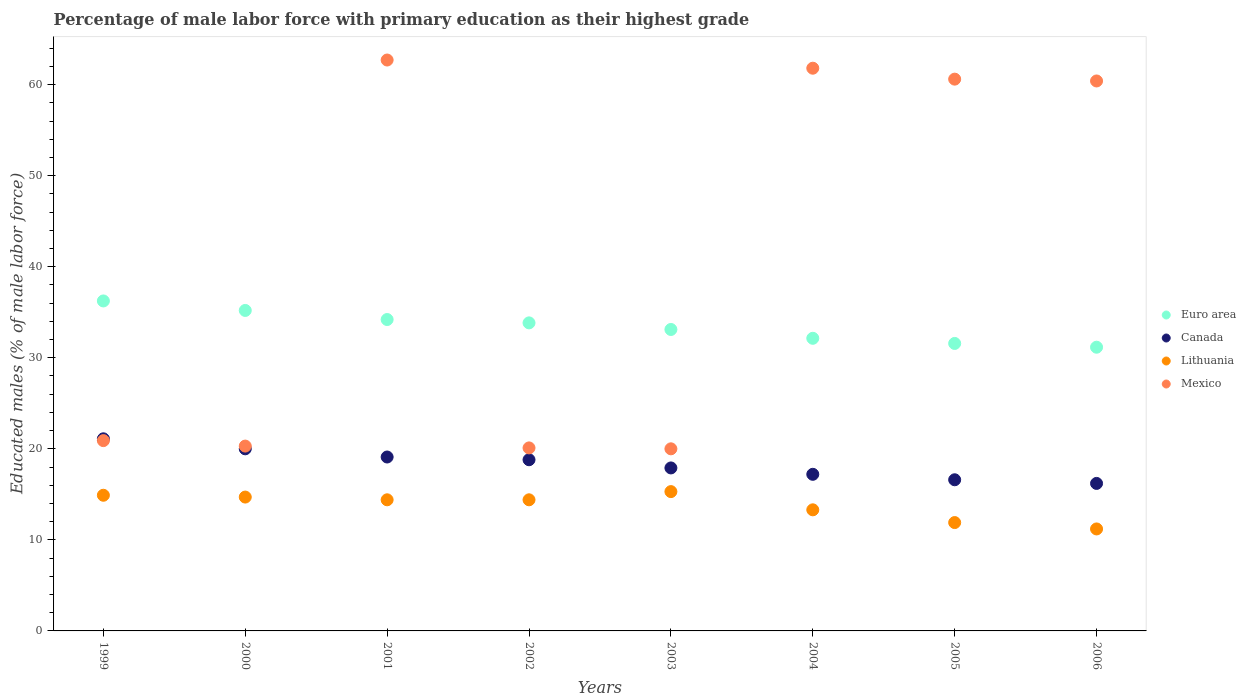How many different coloured dotlines are there?
Keep it short and to the point. 4. What is the percentage of male labor force with primary education in Mexico in 2002?
Your answer should be very brief. 20.1. Across all years, what is the maximum percentage of male labor force with primary education in Mexico?
Offer a terse response. 62.7. Across all years, what is the minimum percentage of male labor force with primary education in Mexico?
Your answer should be compact. 20. In which year was the percentage of male labor force with primary education in Mexico maximum?
Your answer should be compact. 2001. What is the total percentage of male labor force with primary education in Canada in the graph?
Provide a succinct answer. 146.9. What is the difference between the percentage of male labor force with primary education in Canada in 2004 and that in 2005?
Provide a succinct answer. 0.6. What is the difference between the percentage of male labor force with primary education in Euro area in 2002 and the percentage of male labor force with primary education in Canada in 1999?
Your answer should be very brief. 12.73. What is the average percentage of male labor force with primary education in Canada per year?
Offer a terse response. 18.36. In the year 1999, what is the difference between the percentage of male labor force with primary education in Canada and percentage of male labor force with primary education in Lithuania?
Provide a succinct answer. 6.2. In how many years, is the percentage of male labor force with primary education in Lithuania greater than 36 %?
Ensure brevity in your answer.  0. What is the ratio of the percentage of male labor force with primary education in Mexico in 2004 to that in 2006?
Keep it short and to the point. 1.02. What is the difference between the highest and the second highest percentage of male labor force with primary education in Euro area?
Give a very brief answer. 1.04. What is the difference between the highest and the lowest percentage of male labor force with primary education in Mexico?
Make the answer very short. 42.7. In how many years, is the percentage of male labor force with primary education in Canada greater than the average percentage of male labor force with primary education in Canada taken over all years?
Provide a short and direct response. 4. Does the percentage of male labor force with primary education in Canada monotonically increase over the years?
Your answer should be compact. No. How many years are there in the graph?
Keep it short and to the point. 8. Does the graph contain any zero values?
Give a very brief answer. No. Where does the legend appear in the graph?
Ensure brevity in your answer.  Center right. How many legend labels are there?
Offer a terse response. 4. What is the title of the graph?
Make the answer very short. Percentage of male labor force with primary education as their highest grade. What is the label or title of the X-axis?
Your answer should be very brief. Years. What is the label or title of the Y-axis?
Your answer should be very brief. Educated males (% of male labor force). What is the Educated males (% of male labor force) in Euro area in 1999?
Your answer should be very brief. 36.24. What is the Educated males (% of male labor force) of Canada in 1999?
Make the answer very short. 21.1. What is the Educated males (% of male labor force) in Lithuania in 1999?
Make the answer very short. 14.9. What is the Educated males (% of male labor force) in Mexico in 1999?
Offer a very short reply. 20.9. What is the Educated males (% of male labor force) in Euro area in 2000?
Offer a terse response. 35.2. What is the Educated males (% of male labor force) of Lithuania in 2000?
Make the answer very short. 14.7. What is the Educated males (% of male labor force) in Mexico in 2000?
Ensure brevity in your answer.  20.3. What is the Educated males (% of male labor force) of Euro area in 2001?
Provide a short and direct response. 34.2. What is the Educated males (% of male labor force) of Canada in 2001?
Offer a terse response. 19.1. What is the Educated males (% of male labor force) of Lithuania in 2001?
Offer a very short reply. 14.4. What is the Educated males (% of male labor force) in Mexico in 2001?
Keep it short and to the point. 62.7. What is the Educated males (% of male labor force) in Euro area in 2002?
Keep it short and to the point. 33.83. What is the Educated males (% of male labor force) of Canada in 2002?
Offer a very short reply. 18.8. What is the Educated males (% of male labor force) in Lithuania in 2002?
Ensure brevity in your answer.  14.4. What is the Educated males (% of male labor force) in Mexico in 2002?
Give a very brief answer. 20.1. What is the Educated males (% of male labor force) of Euro area in 2003?
Provide a succinct answer. 33.11. What is the Educated males (% of male labor force) of Canada in 2003?
Your answer should be compact. 17.9. What is the Educated males (% of male labor force) in Lithuania in 2003?
Provide a succinct answer. 15.3. What is the Educated males (% of male labor force) in Euro area in 2004?
Give a very brief answer. 32.14. What is the Educated males (% of male labor force) of Canada in 2004?
Your response must be concise. 17.2. What is the Educated males (% of male labor force) in Lithuania in 2004?
Your answer should be compact. 13.3. What is the Educated males (% of male labor force) in Mexico in 2004?
Offer a very short reply. 61.8. What is the Educated males (% of male labor force) of Euro area in 2005?
Make the answer very short. 31.57. What is the Educated males (% of male labor force) in Canada in 2005?
Offer a very short reply. 16.6. What is the Educated males (% of male labor force) in Lithuania in 2005?
Your response must be concise. 11.9. What is the Educated males (% of male labor force) in Mexico in 2005?
Give a very brief answer. 60.6. What is the Educated males (% of male labor force) in Euro area in 2006?
Provide a succinct answer. 31.16. What is the Educated males (% of male labor force) of Canada in 2006?
Give a very brief answer. 16.2. What is the Educated males (% of male labor force) of Lithuania in 2006?
Offer a very short reply. 11.2. What is the Educated males (% of male labor force) of Mexico in 2006?
Your answer should be very brief. 60.4. Across all years, what is the maximum Educated males (% of male labor force) of Euro area?
Ensure brevity in your answer.  36.24. Across all years, what is the maximum Educated males (% of male labor force) of Canada?
Your response must be concise. 21.1. Across all years, what is the maximum Educated males (% of male labor force) in Lithuania?
Your response must be concise. 15.3. Across all years, what is the maximum Educated males (% of male labor force) of Mexico?
Your answer should be very brief. 62.7. Across all years, what is the minimum Educated males (% of male labor force) in Euro area?
Make the answer very short. 31.16. Across all years, what is the minimum Educated males (% of male labor force) of Canada?
Provide a succinct answer. 16.2. Across all years, what is the minimum Educated males (% of male labor force) of Lithuania?
Your response must be concise. 11.2. What is the total Educated males (% of male labor force) in Euro area in the graph?
Your answer should be compact. 267.44. What is the total Educated males (% of male labor force) in Canada in the graph?
Provide a succinct answer. 146.9. What is the total Educated males (% of male labor force) in Lithuania in the graph?
Your answer should be very brief. 110.1. What is the total Educated males (% of male labor force) of Mexico in the graph?
Offer a very short reply. 326.8. What is the difference between the Educated males (% of male labor force) in Euro area in 1999 and that in 2000?
Keep it short and to the point. 1.04. What is the difference between the Educated males (% of male labor force) of Euro area in 1999 and that in 2001?
Provide a succinct answer. 2.04. What is the difference between the Educated males (% of male labor force) in Canada in 1999 and that in 2001?
Provide a short and direct response. 2. What is the difference between the Educated males (% of male labor force) of Lithuania in 1999 and that in 2001?
Ensure brevity in your answer.  0.5. What is the difference between the Educated males (% of male labor force) of Mexico in 1999 and that in 2001?
Your response must be concise. -41.8. What is the difference between the Educated males (% of male labor force) of Euro area in 1999 and that in 2002?
Offer a terse response. 2.41. What is the difference between the Educated males (% of male labor force) of Mexico in 1999 and that in 2002?
Provide a short and direct response. 0.8. What is the difference between the Educated males (% of male labor force) in Euro area in 1999 and that in 2003?
Keep it short and to the point. 3.13. What is the difference between the Educated males (% of male labor force) in Lithuania in 1999 and that in 2003?
Offer a very short reply. -0.4. What is the difference between the Educated males (% of male labor force) in Euro area in 1999 and that in 2004?
Provide a short and direct response. 4.1. What is the difference between the Educated males (% of male labor force) in Lithuania in 1999 and that in 2004?
Give a very brief answer. 1.6. What is the difference between the Educated males (% of male labor force) of Mexico in 1999 and that in 2004?
Provide a succinct answer. -40.9. What is the difference between the Educated males (% of male labor force) in Euro area in 1999 and that in 2005?
Give a very brief answer. 4.67. What is the difference between the Educated males (% of male labor force) in Mexico in 1999 and that in 2005?
Give a very brief answer. -39.7. What is the difference between the Educated males (% of male labor force) in Euro area in 1999 and that in 2006?
Your answer should be compact. 5.08. What is the difference between the Educated males (% of male labor force) of Canada in 1999 and that in 2006?
Give a very brief answer. 4.9. What is the difference between the Educated males (% of male labor force) of Lithuania in 1999 and that in 2006?
Your answer should be very brief. 3.7. What is the difference between the Educated males (% of male labor force) of Mexico in 1999 and that in 2006?
Offer a very short reply. -39.5. What is the difference between the Educated males (% of male labor force) of Canada in 2000 and that in 2001?
Your response must be concise. 0.9. What is the difference between the Educated males (% of male labor force) in Lithuania in 2000 and that in 2001?
Make the answer very short. 0.3. What is the difference between the Educated males (% of male labor force) of Mexico in 2000 and that in 2001?
Your response must be concise. -42.4. What is the difference between the Educated males (% of male labor force) in Euro area in 2000 and that in 2002?
Provide a short and direct response. 1.36. What is the difference between the Educated males (% of male labor force) of Canada in 2000 and that in 2002?
Your response must be concise. 1.2. What is the difference between the Educated males (% of male labor force) of Lithuania in 2000 and that in 2002?
Your answer should be compact. 0.3. What is the difference between the Educated males (% of male labor force) in Mexico in 2000 and that in 2002?
Your response must be concise. 0.2. What is the difference between the Educated males (% of male labor force) of Euro area in 2000 and that in 2003?
Offer a terse response. 2.09. What is the difference between the Educated males (% of male labor force) of Canada in 2000 and that in 2003?
Provide a short and direct response. 2.1. What is the difference between the Educated males (% of male labor force) of Mexico in 2000 and that in 2003?
Make the answer very short. 0.3. What is the difference between the Educated males (% of male labor force) of Euro area in 2000 and that in 2004?
Your response must be concise. 3.06. What is the difference between the Educated males (% of male labor force) in Canada in 2000 and that in 2004?
Your answer should be very brief. 2.8. What is the difference between the Educated males (% of male labor force) of Mexico in 2000 and that in 2004?
Ensure brevity in your answer.  -41.5. What is the difference between the Educated males (% of male labor force) of Euro area in 2000 and that in 2005?
Your response must be concise. 3.62. What is the difference between the Educated males (% of male labor force) in Canada in 2000 and that in 2005?
Your answer should be very brief. 3.4. What is the difference between the Educated males (% of male labor force) of Mexico in 2000 and that in 2005?
Give a very brief answer. -40.3. What is the difference between the Educated males (% of male labor force) of Euro area in 2000 and that in 2006?
Give a very brief answer. 4.04. What is the difference between the Educated males (% of male labor force) in Canada in 2000 and that in 2006?
Ensure brevity in your answer.  3.8. What is the difference between the Educated males (% of male labor force) of Lithuania in 2000 and that in 2006?
Provide a short and direct response. 3.5. What is the difference between the Educated males (% of male labor force) of Mexico in 2000 and that in 2006?
Your answer should be compact. -40.1. What is the difference between the Educated males (% of male labor force) in Euro area in 2001 and that in 2002?
Offer a terse response. 0.37. What is the difference between the Educated males (% of male labor force) in Canada in 2001 and that in 2002?
Your response must be concise. 0.3. What is the difference between the Educated males (% of male labor force) in Lithuania in 2001 and that in 2002?
Make the answer very short. 0. What is the difference between the Educated males (% of male labor force) in Mexico in 2001 and that in 2002?
Your answer should be very brief. 42.6. What is the difference between the Educated males (% of male labor force) in Euro area in 2001 and that in 2003?
Provide a short and direct response. 1.09. What is the difference between the Educated males (% of male labor force) of Canada in 2001 and that in 2003?
Your answer should be very brief. 1.2. What is the difference between the Educated males (% of male labor force) in Mexico in 2001 and that in 2003?
Give a very brief answer. 42.7. What is the difference between the Educated males (% of male labor force) in Euro area in 2001 and that in 2004?
Make the answer very short. 2.06. What is the difference between the Educated males (% of male labor force) in Canada in 2001 and that in 2004?
Offer a very short reply. 1.9. What is the difference between the Educated males (% of male labor force) of Lithuania in 2001 and that in 2004?
Offer a very short reply. 1.1. What is the difference between the Educated males (% of male labor force) in Mexico in 2001 and that in 2004?
Offer a terse response. 0.9. What is the difference between the Educated males (% of male labor force) in Euro area in 2001 and that in 2005?
Give a very brief answer. 2.63. What is the difference between the Educated males (% of male labor force) in Canada in 2001 and that in 2005?
Keep it short and to the point. 2.5. What is the difference between the Educated males (% of male labor force) of Euro area in 2001 and that in 2006?
Make the answer very short. 3.04. What is the difference between the Educated males (% of male labor force) of Canada in 2001 and that in 2006?
Ensure brevity in your answer.  2.9. What is the difference between the Educated males (% of male labor force) in Lithuania in 2001 and that in 2006?
Your response must be concise. 3.2. What is the difference between the Educated males (% of male labor force) of Euro area in 2002 and that in 2003?
Your answer should be compact. 0.72. What is the difference between the Educated males (% of male labor force) of Canada in 2002 and that in 2003?
Provide a succinct answer. 0.9. What is the difference between the Educated males (% of male labor force) in Lithuania in 2002 and that in 2003?
Offer a terse response. -0.9. What is the difference between the Educated males (% of male labor force) of Mexico in 2002 and that in 2003?
Offer a terse response. 0.1. What is the difference between the Educated males (% of male labor force) in Euro area in 2002 and that in 2004?
Make the answer very short. 1.69. What is the difference between the Educated males (% of male labor force) of Mexico in 2002 and that in 2004?
Your answer should be compact. -41.7. What is the difference between the Educated males (% of male labor force) in Euro area in 2002 and that in 2005?
Offer a terse response. 2.26. What is the difference between the Educated males (% of male labor force) in Mexico in 2002 and that in 2005?
Your answer should be very brief. -40.5. What is the difference between the Educated males (% of male labor force) of Euro area in 2002 and that in 2006?
Offer a terse response. 2.67. What is the difference between the Educated males (% of male labor force) in Canada in 2002 and that in 2006?
Your answer should be compact. 2.6. What is the difference between the Educated males (% of male labor force) in Mexico in 2002 and that in 2006?
Your answer should be very brief. -40.3. What is the difference between the Educated males (% of male labor force) of Euro area in 2003 and that in 2004?
Your answer should be very brief. 0.97. What is the difference between the Educated males (% of male labor force) of Mexico in 2003 and that in 2004?
Your answer should be very brief. -41.8. What is the difference between the Educated males (% of male labor force) in Euro area in 2003 and that in 2005?
Your answer should be compact. 1.53. What is the difference between the Educated males (% of male labor force) in Mexico in 2003 and that in 2005?
Provide a short and direct response. -40.6. What is the difference between the Educated males (% of male labor force) in Euro area in 2003 and that in 2006?
Offer a very short reply. 1.95. What is the difference between the Educated males (% of male labor force) of Mexico in 2003 and that in 2006?
Offer a terse response. -40.4. What is the difference between the Educated males (% of male labor force) in Euro area in 2004 and that in 2005?
Give a very brief answer. 0.57. What is the difference between the Educated males (% of male labor force) of Canada in 2004 and that in 2005?
Give a very brief answer. 0.6. What is the difference between the Educated males (% of male labor force) in Euro area in 2004 and that in 2006?
Provide a succinct answer. 0.98. What is the difference between the Educated males (% of male labor force) in Lithuania in 2004 and that in 2006?
Keep it short and to the point. 2.1. What is the difference between the Educated males (% of male labor force) of Mexico in 2004 and that in 2006?
Provide a succinct answer. 1.4. What is the difference between the Educated males (% of male labor force) of Euro area in 2005 and that in 2006?
Offer a terse response. 0.41. What is the difference between the Educated males (% of male labor force) of Lithuania in 2005 and that in 2006?
Offer a very short reply. 0.7. What is the difference between the Educated males (% of male labor force) in Euro area in 1999 and the Educated males (% of male labor force) in Canada in 2000?
Your answer should be compact. 16.24. What is the difference between the Educated males (% of male labor force) of Euro area in 1999 and the Educated males (% of male labor force) of Lithuania in 2000?
Offer a terse response. 21.54. What is the difference between the Educated males (% of male labor force) of Euro area in 1999 and the Educated males (% of male labor force) of Mexico in 2000?
Make the answer very short. 15.94. What is the difference between the Educated males (% of male labor force) in Canada in 1999 and the Educated males (% of male labor force) in Lithuania in 2000?
Offer a very short reply. 6.4. What is the difference between the Educated males (% of male labor force) of Canada in 1999 and the Educated males (% of male labor force) of Mexico in 2000?
Your answer should be very brief. 0.8. What is the difference between the Educated males (% of male labor force) of Lithuania in 1999 and the Educated males (% of male labor force) of Mexico in 2000?
Your answer should be compact. -5.4. What is the difference between the Educated males (% of male labor force) of Euro area in 1999 and the Educated males (% of male labor force) of Canada in 2001?
Your answer should be compact. 17.14. What is the difference between the Educated males (% of male labor force) in Euro area in 1999 and the Educated males (% of male labor force) in Lithuania in 2001?
Make the answer very short. 21.84. What is the difference between the Educated males (% of male labor force) of Euro area in 1999 and the Educated males (% of male labor force) of Mexico in 2001?
Ensure brevity in your answer.  -26.46. What is the difference between the Educated males (% of male labor force) of Canada in 1999 and the Educated males (% of male labor force) of Lithuania in 2001?
Offer a terse response. 6.7. What is the difference between the Educated males (% of male labor force) in Canada in 1999 and the Educated males (% of male labor force) in Mexico in 2001?
Provide a succinct answer. -41.6. What is the difference between the Educated males (% of male labor force) in Lithuania in 1999 and the Educated males (% of male labor force) in Mexico in 2001?
Make the answer very short. -47.8. What is the difference between the Educated males (% of male labor force) of Euro area in 1999 and the Educated males (% of male labor force) of Canada in 2002?
Offer a terse response. 17.44. What is the difference between the Educated males (% of male labor force) of Euro area in 1999 and the Educated males (% of male labor force) of Lithuania in 2002?
Provide a short and direct response. 21.84. What is the difference between the Educated males (% of male labor force) in Euro area in 1999 and the Educated males (% of male labor force) in Mexico in 2002?
Provide a succinct answer. 16.14. What is the difference between the Educated males (% of male labor force) of Canada in 1999 and the Educated males (% of male labor force) of Lithuania in 2002?
Offer a terse response. 6.7. What is the difference between the Educated males (% of male labor force) in Euro area in 1999 and the Educated males (% of male labor force) in Canada in 2003?
Provide a succinct answer. 18.34. What is the difference between the Educated males (% of male labor force) in Euro area in 1999 and the Educated males (% of male labor force) in Lithuania in 2003?
Offer a very short reply. 20.94. What is the difference between the Educated males (% of male labor force) of Euro area in 1999 and the Educated males (% of male labor force) of Mexico in 2003?
Keep it short and to the point. 16.24. What is the difference between the Educated males (% of male labor force) in Canada in 1999 and the Educated males (% of male labor force) in Lithuania in 2003?
Your response must be concise. 5.8. What is the difference between the Educated males (% of male labor force) in Canada in 1999 and the Educated males (% of male labor force) in Mexico in 2003?
Offer a very short reply. 1.1. What is the difference between the Educated males (% of male labor force) of Euro area in 1999 and the Educated males (% of male labor force) of Canada in 2004?
Provide a short and direct response. 19.04. What is the difference between the Educated males (% of male labor force) of Euro area in 1999 and the Educated males (% of male labor force) of Lithuania in 2004?
Provide a succinct answer. 22.94. What is the difference between the Educated males (% of male labor force) of Euro area in 1999 and the Educated males (% of male labor force) of Mexico in 2004?
Give a very brief answer. -25.56. What is the difference between the Educated males (% of male labor force) of Canada in 1999 and the Educated males (% of male labor force) of Lithuania in 2004?
Your response must be concise. 7.8. What is the difference between the Educated males (% of male labor force) in Canada in 1999 and the Educated males (% of male labor force) in Mexico in 2004?
Make the answer very short. -40.7. What is the difference between the Educated males (% of male labor force) of Lithuania in 1999 and the Educated males (% of male labor force) of Mexico in 2004?
Make the answer very short. -46.9. What is the difference between the Educated males (% of male labor force) in Euro area in 1999 and the Educated males (% of male labor force) in Canada in 2005?
Ensure brevity in your answer.  19.64. What is the difference between the Educated males (% of male labor force) in Euro area in 1999 and the Educated males (% of male labor force) in Lithuania in 2005?
Offer a terse response. 24.34. What is the difference between the Educated males (% of male labor force) in Euro area in 1999 and the Educated males (% of male labor force) in Mexico in 2005?
Provide a succinct answer. -24.36. What is the difference between the Educated males (% of male labor force) of Canada in 1999 and the Educated males (% of male labor force) of Mexico in 2005?
Provide a short and direct response. -39.5. What is the difference between the Educated males (% of male labor force) in Lithuania in 1999 and the Educated males (% of male labor force) in Mexico in 2005?
Make the answer very short. -45.7. What is the difference between the Educated males (% of male labor force) of Euro area in 1999 and the Educated males (% of male labor force) of Canada in 2006?
Provide a succinct answer. 20.04. What is the difference between the Educated males (% of male labor force) in Euro area in 1999 and the Educated males (% of male labor force) in Lithuania in 2006?
Give a very brief answer. 25.04. What is the difference between the Educated males (% of male labor force) of Euro area in 1999 and the Educated males (% of male labor force) of Mexico in 2006?
Your answer should be very brief. -24.16. What is the difference between the Educated males (% of male labor force) of Canada in 1999 and the Educated males (% of male labor force) of Mexico in 2006?
Offer a very short reply. -39.3. What is the difference between the Educated males (% of male labor force) of Lithuania in 1999 and the Educated males (% of male labor force) of Mexico in 2006?
Keep it short and to the point. -45.5. What is the difference between the Educated males (% of male labor force) in Euro area in 2000 and the Educated males (% of male labor force) in Canada in 2001?
Offer a terse response. 16.1. What is the difference between the Educated males (% of male labor force) in Euro area in 2000 and the Educated males (% of male labor force) in Lithuania in 2001?
Give a very brief answer. 20.8. What is the difference between the Educated males (% of male labor force) of Euro area in 2000 and the Educated males (% of male labor force) of Mexico in 2001?
Keep it short and to the point. -27.5. What is the difference between the Educated males (% of male labor force) in Canada in 2000 and the Educated males (% of male labor force) in Mexico in 2001?
Your answer should be compact. -42.7. What is the difference between the Educated males (% of male labor force) of Lithuania in 2000 and the Educated males (% of male labor force) of Mexico in 2001?
Your answer should be very brief. -48. What is the difference between the Educated males (% of male labor force) of Euro area in 2000 and the Educated males (% of male labor force) of Canada in 2002?
Provide a short and direct response. 16.4. What is the difference between the Educated males (% of male labor force) in Euro area in 2000 and the Educated males (% of male labor force) in Lithuania in 2002?
Offer a very short reply. 20.8. What is the difference between the Educated males (% of male labor force) in Euro area in 2000 and the Educated males (% of male labor force) in Mexico in 2002?
Provide a succinct answer. 15.1. What is the difference between the Educated males (% of male labor force) of Lithuania in 2000 and the Educated males (% of male labor force) of Mexico in 2002?
Offer a terse response. -5.4. What is the difference between the Educated males (% of male labor force) of Euro area in 2000 and the Educated males (% of male labor force) of Canada in 2003?
Offer a very short reply. 17.3. What is the difference between the Educated males (% of male labor force) in Euro area in 2000 and the Educated males (% of male labor force) in Lithuania in 2003?
Provide a succinct answer. 19.9. What is the difference between the Educated males (% of male labor force) of Euro area in 2000 and the Educated males (% of male labor force) of Mexico in 2003?
Make the answer very short. 15.2. What is the difference between the Educated males (% of male labor force) of Canada in 2000 and the Educated males (% of male labor force) of Lithuania in 2003?
Your answer should be very brief. 4.7. What is the difference between the Educated males (% of male labor force) in Lithuania in 2000 and the Educated males (% of male labor force) in Mexico in 2003?
Your answer should be very brief. -5.3. What is the difference between the Educated males (% of male labor force) in Euro area in 2000 and the Educated males (% of male labor force) in Canada in 2004?
Ensure brevity in your answer.  18. What is the difference between the Educated males (% of male labor force) of Euro area in 2000 and the Educated males (% of male labor force) of Lithuania in 2004?
Keep it short and to the point. 21.9. What is the difference between the Educated males (% of male labor force) of Euro area in 2000 and the Educated males (% of male labor force) of Mexico in 2004?
Make the answer very short. -26.6. What is the difference between the Educated males (% of male labor force) in Canada in 2000 and the Educated males (% of male labor force) in Mexico in 2004?
Make the answer very short. -41.8. What is the difference between the Educated males (% of male labor force) of Lithuania in 2000 and the Educated males (% of male labor force) of Mexico in 2004?
Offer a terse response. -47.1. What is the difference between the Educated males (% of male labor force) in Euro area in 2000 and the Educated males (% of male labor force) in Canada in 2005?
Ensure brevity in your answer.  18.6. What is the difference between the Educated males (% of male labor force) in Euro area in 2000 and the Educated males (% of male labor force) in Lithuania in 2005?
Provide a short and direct response. 23.3. What is the difference between the Educated males (% of male labor force) in Euro area in 2000 and the Educated males (% of male labor force) in Mexico in 2005?
Your answer should be compact. -25.4. What is the difference between the Educated males (% of male labor force) of Canada in 2000 and the Educated males (% of male labor force) of Mexico in 2005?
Provide a short and direct response. -40.6. What is the difference between the Educated males (% of male labor force) of Lithuania in 2000 and the Educated males (% of male labor force) of Mexico in 2005?
Provide a succinct answer. -45.9. What is the difference between the Educated males (% of male labor force) of Euro area in 2000 and the Educated males (% of male labor force) of Canada in 2006?
Offer a terse response. 19. What is the difference between the Educated males (% of male labor force) in Euro area in 2000 and the Educated males (% of male labor force) in Lithuania in 2006?
Your answer should be compact. 24. What is the difference between the Educated males (% of male labor force) in Euro area in 2000 and the Educated males (% of male labor force) in Mexico in 2006?
Provide a succinct answer. -25.2. What is the difference between the Educated males (% of male labor force) in Canada in 2000 and the Educated males (% of male labor force) in Lithuania in 2006?
Make the answer very short. 8.8. What is the difference between the Educated males (% of male labor force) in Canada in 2000 and the Educated males (% of male labor force) in Mexico in 2006?
Offer a terse response. -40.4. What is the difference between the Educated males (% of male labor force) of Lithuania in 2000 and the Educated males (% of male labor force) of Mexico in 2006?
Your answer should be compact. -45.7. What is the difference between the Educated males (% of male labor force) of Euro area in 2001 and the Educated males (% of male labor force) of Canada in 2002?
Ensure brevity in your answer.  15.4. What is the difference between the Educated males (% of male labor force) in Euro area in 2001 and the Educated males (% of male labor force) in Lithuania in 2002?
Keep it short and to the point. 19.8. What is the difference between the Educated males (% of male labor force) in Euro area in 2001 and the Educated males (% of male labor force) in Mexico in 2002?
Your answer should be very brief. 14.1. What is the difference between the Educated males (% of male labor force) of Canada in 2001 and the Educated males (% of male labor force) of Lithuania in 2002?
Your answer should be very brief. 4.7. What is the difference between the Educated males (% of male labor force) of Lithuania in 2001 and the Educated males (% of male labor force) of Mexico in 2002?
Give a very brief answer. -5.7. What is the difference between the Educated males (% of male labor force) in Euro area in 2001 and the Educated males (% of male labor force) in Canada in 2003?
Offer a very short reply. 16.3. What is the difference between the Educated males (% of male labor force) in Euro area in 2001 and the Educated males (% of male labor force) in Lithuania in 2003?
Offer a very short reply. 18.9. What is the difference between the Educated males (% of male labor force) of Euro area in 2001 and the Educated males (% of male labor force) of Mexico in 2003?
Your answer should be compact. 14.2. What is the difference between the Educated males (% of male labor force) in Canada in 2001 and the Educated males (% of male labor force) in Lithuania in 2003?
Keep it short and to the point. 3.8. What is the difference between the Educated males (% of male labor force) in Canada in 2001 and the Educated males (% of male labor force) in Mexico in 2003?
Your answer should be very brief. -0.9. What is the difference between the Educated males (% of male labor force) of Lithuania in 2001 and the Educated males (% of male labor force) of Mexico in 2003?
Give a very brief answer. -5.6. What is the difference between the Educated males (% of male labor force) of Euro area in 2001 and the Educated males (% of male labor force) of Canada in 2004?
Keep it short and to the point. 17. What is the difference between the Educated males (% of male labor force) of Euro area in 2001 and the Educated males (% of male labor force) of Lithuania in 2004?
Provide a short and direct response. 20.9. What is the difference between the Educated males (% of male labor force) of Euro area in 2001 and the Educated males (% of male labor force) of Mexico in 2004?
Provide a succinct answer. -27.6. What is the difference between the Educated males (% of male labor force) of Canada in 2001 and the Educated males (% of male labor force) of Mexico in 2004?
Provide a succinct answer. -42.7. What is the difference between the Educated males (% of male labor force) in Lithuania in 2001 and the Educated males (% of male labor force) in Mexico in 2004?
Offer a very short reply. -47.4. What is the difference between the Educated males (% of male labor force) in Euro area in 2001 and the Educated males (% of male labor force) in Canada in 2005?
Provide a succinct answer. 17.6. What is the difference between the Educated males (% of male labor force) of Euro area in 2001 and the Educated males (% of male labor force) of Lithuania in 2005?
Offer a very short reply. 22.3. What is the difference between the Educated males (% of male labor force) of Euro area in 2001 and the Educated males (% of male labor force) of Mexico in 2005?
Ensure brevity in your answer.  -26.4. What is the difference between the Educated males (% of male labor force) of Canada in 2001 and the Educated males (% of male labor force) of Mexico in 2005?
Provide a short and direct response. -41.5. What is the difference between the Educated males (% of male labor force) in Lithuania in 2001 and the Educated males (% of male labor force) in Mexico in 2005?
Ensure brevity in your answer.  -46.2. What is the difference between the Educated males (% of male labor force) in Euro area in 2001 and the Educated males (% of male labor force) in Canada in 2006?
Provide a short and direct response. 18. What is the difference between the Educated males (% of male labor force) in Euro area in 2001 and the Educated males (% of male labor force) in Lithuania in 2006?
Offer a very short reply. 23. What is the difference between the Educated males (% of male labor force) of Euro area in 2001 and the Educated males (% of male labor force) of Mexico in 2006?
Your answer should be compact. -26.2. What is the difference between the Educated males (% of male labor force) in Canada in 2001 and the Educated males (% of male labor force) in Mexico in 2006?
Provide a succinct answer. -41.3. What is the difference between the Educated males (% of male labor force) in Lithuania in 2001 and the Educated males (% of male labor force) in Mexico in 2006?
Your answer should be very brief. -46. What is the difference between the Educated males (% of male labor force) of Euro area in 2002 and the Educated males (% of male labor force) of Canada in 2003?
Offer a very short reply. 15.93. What is the difference between the Educated males (% of male labor force) in Euro area in 2002 and the Educated males (% of male labor force) in Lithuania in 2003?
Offer a terse response. 18.53. What is the difference between the Educated males (% of male labor force) in Euro area in 2002 and the Educated males (% of male labor force) in Mexico in 2003?
Your response must be concise. 13.83. What is the difference between the Educated males (% of male labor force) of Canada in 2002 and the Educated males (% of male labor force) of Lithuania in 2003?
Your response must be concise. 3.5. What is the difference between the Educated males (% of male labor force) of Canada in 2002 and the Educated males (% of male labor force) of Mexico in 2003?
Your answer should be compact. -1.2. What is the difference between the Educated males (% of male labor force) of Lithuania in 2002 and the Educated males (% of male labor force) of Mexico in 2003?
Provide a succinct answer. -5.6. What is the difference between the Educated males (% of male labor force) of Euro area in 2002 and the Educated males (% of male labor force) of Canada in 2004?
Make the answer very short. 16.63. What is the difference between the Educated males (% of male labor force) of Euro area in 2002 and the Educated males (% of male labor force) of Lithuania in 2004?
Your response must be concise. 20.53. What is the difference between the Educated males (% of male labor force) of Euro area in 2002 and the Educated males (% of male labor force) of Mexico in 2004?
Your answer should be compact. -27.97. What is the difference between the Educated males (% of male labor force) of Canada in 2002 and the Educated males (% of male labor force) of Mexico in 2004?
Your answer should be compact. -43. What is the difference between the Educated males (% of male labor force) in Lithuania in 2002 and the Educated males (% of male labor force) in Mexico in 2004?
Your answer should be compact. -47.4. What is the difference between the Educated males (% of male labor force) of Euro area in 2002 and the Educated males (% of male labor force) of Canada in 2005?
Give a very brief answer. 17.23. What is the difference between the Educated males (% of male labor force) in Euro area in 2002 and the Educated males (% of male labor force) in Lithuania in 2005?
Your answer should be compact. 21.93. What is the difference between the Educated males (% of male labor force) of Euro area in 2002 and the Educated males (% of male labor force) of Mexico in 2005?
Make the answer very short. -26.77. What is the difference between the Educated males (% of male labor force) in Canada in 2002 and the Educated males (% of male labor force) in Lithuania in 2005?
Make the answer very short. 6.9. What is the difference between the Educated males (% of male labor force) of Canada in 2002 and the Educated males (% of male labor force) of Mexico in 2005?
Make the answer very short. -41.8. What is the difference between the Educated males (% of male labor force) in Lithuania in 2002 and the Educated males (% of male labor force) in Mexico in 2005?
Give a very brief answer. -46.2. What is the difference between the Educated males (% of male labor force) in Euro area in 2002 and the Educated males (% of male labor force) in Canada in 2006?
Your answer should be very brief. 17.63. What is the difference between the Educated males (% of male labor force) of Euro area in 2002 and the Educated males (% of male labor force) of Lithuania in 2006?
Give a very brief answer. 22.63. What is the difference between the Educated males (% of male labor force) in Euro area in 2002 and the Educated males (% of male labor force) in Mexico in 2006?
Your answer should be compact. -26.57. What is the difference between the Educated males (% of male labor force) in Canada in 2002 and the Educated males (% of male labor force) in Mexico in 2006?
Ensure brevity in your answer.  -41.6. What is the difference between the Educated males (% of male labor force) of Lithuania in 2002 and the Educated males (% of male labor force) of Mexico in 2006?
Provide a short and direct response. -46. What is the difference between the Educated males (% of male labor force) of Euro area in 2003 and the Educated males (% of male labor force) of Canada in 2004?
Your response must be concise. 15.91. What is the difference between the Educated males (% of male labor force) of Euro area in 2003 and the Educated males (% of male labor force) of Lithuania in 2004?
Provide a succinct answer. 19.81. What is the difference between the Educated males (% of male labor force) of Euro area in 2003 and the Educated males (% of male labor force) of Mexico in 2004?
Keep it short and to the point. -28.69. What is the difference between the Educated males (% of male labor force) of Canada in 2003 and the Educated males (% of male labor force) of Lithuania in 2004?
Make the answer very short. 4.6. What is the difference between the Educated males (% of male labor force) in Canada in 2003 and the Educated males (% of male labor force) in Mexico in 2004?
Provide a short and direct response. -43.9. What is the difference between the Educated males (% of male labor force) in Lithuania in 2003 and the Educated males (% of male labor force) in Mexico in 2004?
Your response must be concise. -46.5. What is the difference between the Educated males (% of male labor force) of Euro area in 2003 and the Educated males (% of male labor force) of Canada in 2005?
Provide a short and direct response. 16.51. What is the difference between the Educated males (% of male labor force) in Euro area in 2003 and the Educated males (% of male labor force) in Lithuania in 2005?
Provide a succinct answer. 21.21. What is the difference between the Educated males (% of male labor force) of Euro area in 2003 and the Educated males (% of male labor force) of Mexico in 2005?
Your answer should be very brief. -27.49. What is the difference between the Educated males (% of male labor force) of Canada in 2003 and the Educated males (% of male labor force) of Mexico in 2005?
Your answer should be very brief. -42.7. What is the difference between the Educated males (% of male labor force) of Lithuania in 2003 and the Educated males (% of male labor force) of Mexico in 2005?
Offer a very short reply. -45.3. What is the difference between the Educated males (% of male labor force) of Euro area in 2003 and the Educated males (% of male labor force) of Canada in 2006?
Your response must be concise. 16.91. What is the difference between the Educated males (% of male labor force) in Euro area in 2003 and the Educated males (% of male labor force) in Lithuania in 2006?
Your response must be concise. 21.91. What is the difference between the Educated males (% of male labor force) in Euro area in 2003 and the Educated males (% of male labor force) in Mexico in 2006?
Keep it short and to the point. -27.29. What is the difference between the Educated males (% of male labor force) of Canada in 2003 and the Educated males (% of male labor force) of Lithuania in 2006?
Your response must be concise. 6.7. What is the difference between the Educated males (% of male labor force) of Canada in 2003 and the Educated males (% of male labor force) of Mexico in 2006?
Provide a succinct answer. -42.5. What is the difference between the Educated males (% of male labor force) of Lithuania in 2003 and the Educated males (% of male labor force) of Mexico in 2006?
Offer a terse response. -45.1. What is the difference between the Educated males (% of male labor force) of Euro area in 2004 and the Educated males (% of male labor force) of Canada in 2005?
Make the answer very short. 15.54. What is the difference between the Educated males (% of male labor force) of Euro area in 2004 and the Educated males (% of male labor force) of Lithuania in 2005?
Your answer should be compact. 20.24. What is the difference between the Educated males (% of male labor force) of Euro area in 2004 and the Educated males (% of male labor force) of Mexico in 2005?
Offer a very short reply. -28.46. What is the difference between the Educated males (% of male labor force) in Canada in 2004 and the Educated males (% of male labor force) in Lithuania in 2005?
Make the answer very short. 5.3. What is the difference between the Educated males (% of male labor force) in Canada in 2004 and the Educated males (% of male labor force) in Mexico in 2005?
Offer a terse response. -43.4. What is the difference between the Educated males (% of male labor force) of Lithuania in 2004 and the Educated males (% of male labor force) of Mexico in 2005?
Provide a short and direct response. -47.3. What is the difference between the Educated males (% of male labor force) in Euro area in 2004 and the Educated males (% of male labor force) in Canada in 2006?
Your answer should be compact. 15.94. What is the difference between the Educated males (% of male labor force) in Euro area in 2004 and the Educated males (% of male labor force) in Lithuania in 2006?
Your answer should be compact. 20.94. What is the difference between the Educated males (% of male labor force) of Euro area in 2004 and the Educated males (% of male labor force) of Mexico in 2006?
Ensure brevity in your answer.  -28.26. What is the difference between the Educated males (% of male labor force) of Canada in 2004 and the Educated males (% of male labor force) of Mexico in 2006?
Your response must be concise. -43.2. What is the difference between the Educated males (% of male labor force) in Lithuania in 2004 and the Educated males (% of male labor force) in Mexico in 2006?
Your answer should be very brief. -47.1. What is the difference between the Educated males (% of male labor force) of Euro area in 2005 and the Educated males (% of male labor force) of Canada in 2006?
Give a very brief answer. 15.37. What is the difference between the Educated males (% of male labor force) in Euro area in 2005 and the Educated males (% of male labor force) in Lithuania in 2006?
Your response must be concise. 20.37. What is the difference between the Educated males (% of male labor force) in Euro area in 2005 and the Educated males (% of male labor force) in Mexico in 2006?
Your answer should be very brief. -28.83. What is the difference between the Educated males (% of male labor force) of Canada in 2005 and the Educated males (% of male labor force) of Mexico in 2006?
Provide a short and direct response. -43.8. What is the difference between the Educated males (% of male labor force) of Lithuania in 2005 and the Educated males (% of male labor force) of Mexico in 2006?
Your answer should be very brief. -48.5. What is the average Educated males (% of male labor force) in Euro area per year?
Offer a very short reply. 33.43. What is the average Educated males (% of male labor force) in Canada per year?
Offer a terse response. 18.36. What is the average Educated males (% of male labor force) in Lithuania per year?
Make the answer very short. 13.76. What is the average Educated males (% of male labor force) of Mexico per year?
Provide a short and direct response. 40.85. In the year 1999, what is the difference between the Educated males (% of male labor force) in Euro area and Educated males (% of male labor force) in Canada?
Your answer should be very brief. 15.14. In the year 1999, what is the difference between the Educated males (% of male labor force) in Euro area and Educated males (% of male labor force) in Lithuania?
Provide a succinct answer. 21.34. In the year 1999, what is the difference between the Educated males (% of male labor force) in Euro area and Educated males (% of male labor force) in Mexico?
Provide a succinct answer. 15.34. In the year 2000, what is the difference between the Educated males (% of male labor force) in Euro area and Educated males (% of male labor force) in Canada?
Ensure brevity in your answer.  15.2. In the year 2000, what is the difference between the Educated males (% of male labor force) of Euro area and Educated males (% of male labor force) of Lithuania?
Your answer should be very brief. 20.5. In the year 2000, what is the difference between the Educated males (% of male labor force) of Euro area and Educated males (% of male labor force) of Mexico?
Offer a terse response. 14.9. In the year 2001, what is the difference between the Educated males (% of male labor force) in Euro area and Educated males (% of male labor force) in Canada?
Make the answer very short. 15.1. In the year 2001, what is the difference between the Educated males (% of male labor force) of Euro area and Educated males (% of male labor force) of Lithuania?
Make the answer very short. 19.8. In the year 2001, what is the difference between the Educated males (% of male labor force) of Euro area and Educated males (% of male labor force) of Mexico?
Your answer should be very brief. -28.5. In the year 2001, what is the difference between the Educated males (% of male labor force) in Canada and Educated males (% of male labor force) in Lithuania?
Ensure brevity in your answer.  4.7. In the year 2001, what is the difference between the Educated males (% of male labor force) in Canada and Educated males (% of male labor force) in Mexico?
Your response must be concise. -43.6. In the year 2001, what is the difference between the Educated males (% of male labor force) in Lithuania and Educated males (% of male labor force) in Mexico?
Your answer should be very brief. -48.3. In the year 2002, what is the difference between the Educated males (% of male labor force) in Euro area and Educated males (% of male labor force) in Canada?
Your answer should be compact. 15.03. In the year 2002, what is the difference between the Educated males (% of male labor force) of Euro area and Educated males (% of male labor force) of Lithuania?
Your response must be concise. 19.43. In the year 2002, what is the difference between the Educated males (% of male labor force) of Euro area and Educated males (% of male labor force) of Mexico?
Give a very brief answer. 13.73. In the year 2002, what is the difference between the Educated males (% of male labor force) of Canada and Educated males (% of male labor force) of Lithuania?
Give a very brief answer. 4.4. In the year 2002, what is the difference between the Educated males (% of male labor force) in Lithuania and Educated males (% of male labor force) in Mexico?
Your answer should be compact. -5.7. In the year 2003, what is the difference between the Educated males (% of male labor force) of Euro area and Educated males (% of male labor force) of Canada?
Provide a short and direct response. 15.21. In the year 2003, what is the difference between the Educated males (% of male labor force) in Euro area and Educated males (% of male labor force) in Lithuania?
Provide a short and direct response. 17.81. In the year 2003, what is the difference between the Educated males (% of male labor force) in Euro area and Educated males (% of male labor force) in Mexico?
Give a very brief answer. 13.11. In the year 2003, what is the difference between the Educated males (% of male labor force) in Canada and Educated males (% of male labor force) in Mexico?
Provide a succinct answer. -2.1. In the year 2003, what is the difference between the Educated males (% of male labor force) in Lithuania and Educated males (% of male labor force) in Mexico?
Your answer should be very brief. -4.7. In the year 2004, what is the difference between the Educated males (% of male labor force) in Euro area and Educated males (% of male labor force) in Canada?
Make the answer very short. 14.94. In the year 2004, what is the difference between the Educated males (% of male labor force) in Euro area and Educated males (% of male labor force) in Lithuania?
Keep it short and to the point. 18.84. In the year 2004, what is the difference between the Educated males (% of male labor force) of Euro area and Educated males (% of male labor force) of Mexico?
Ensure brevity in your answer.  -29.66. In the year 2004, what is the difference between the Educated males (% of male labor force) of Canada and Educated males (% of male labor force) of Lithuania?
Provide a short and direct response. 3.9. In the year 2004, what is the difference between the Educated males (% of male labor force) of Canada and Educated males (% of male labor force) of Mexico?
Offer a very short reply. -44.6. In the year 2004, what is the difference between the Educated males (% of male labor force) of Lithuania and Educated males (% of male labor force) of Mexico?
Give a very brief answer. -48.5. In the year 2005, what is the difference between the Educated males (% of male labor force) in Euro area and Educated males (% of male labor force) in Canada?
Your answer should be very brief. 14.97. In the year 2005, what is the difference between the Educated males (% of male labor force) in Euro area and Educated males (% of male labor force) in Lithuania?
Make the answer very short. 19.67. In the year 2005, what is the difference between the Educated males (% of male labor force) in Euro area and Educated males (% of male labor force) in Mexico?
Your response must be concise. -29.03. In the year 2005, what is the difference between the Educated males (% of male labor force) in Canada and Educated males (% of male labor force) in Mexico?
Ensure brevity in your answer.  -44. In the year 2005, what is the difference between the Educated males (% of male labor force) in Lithuania and Educated males (% of male labor force) in Mexico?
Provide a succinct answer. -48.7. In the year 2006, what is the difference between the Educated males (% of male labor force) of Euro area and Educated males (% of male labor force) of Canada?
Your response must be concise. 14.96. In the year 2006, what is the difference between the Educated males (% of male labor force) of Euro area and Educated males (% of male labor force) of Lithuania?
Offer a terse response. 19.96. In the year 2006, what is the difference between the Educated males (% of male labor force) of Euro area and Educated males (% of male labor force) of Mexico?
Your answer should be compact. -29.24. In the year 2006, what is the difference between the Educated males (% of male labor force) of Canada and Educated males (% of male labor force) of Mexico?
Offer a very short reply. -44.2. In the year 2006, what is the difference between the Educated males (% of male labor force) in Lithuania and Educated males (% of male labor force) in Mexico?
Offer a very short reply. -49.2. What is the ratio of the Educated males (% of male labor force) of Euro area in 1999 to that in 2000?
Give a very brief answer. 1.03. What is the ratio of the Educated males (% of male labor force) in Canada in 1999 to that in 2000?
Give a very brief answer. 1.05. What is the ratio of the Educated males (% of male labor force) of Lithuania in 1999 to that in 2000?
Your answer should be compact. 1.01. What is the ratio of the Educated males (% of male labor force) in Mexico in 1999 to that in 2000?
Keep it short and to the point. 1.03. What is the ratio of the Educated males (% of male labor force) of Euro area in 1999 to that in 2001?
Your response must be concise. 1.06. What is the ratio of the Educated males (% of male labor force) in Canada in 1999 to that in 2001?
Keep it short and to the point. 1.1. What is the ratio of the Educated males (% of male labor force) in Lithuania in 1999 to that in 2001?
Your answer should be very brief. 1.03. What is the ratio of the Educated males (% of male labor force) in Euro area in 1999 to that in 2002?
Ensure brevity in your answer.  1.07. What is the ratio of the Educated males (% of male labor force) in Canada in 1999 to that in 2002?
Offer a terse response. 1.12. What is the ratio of the Educated males (% of male labor force) in Lithuania in 1999 to that in 2002?
Keep it short and to the point. 1.03. What is the ratio of the Educated males (% of male labor force) in Mexico in 1999 to that in 2002?
Your response must be concise. 1.04. What is the ratio of the Educated males (% of male labor force) in Euro area in 1999 to that in 2003?
Offer a terse response. 1.09. What is the ratio of the Educated males (% of male labor force) of Canada in 1999 to that in 2003?
Your answer should be very brief. 1.18. What is the ratio of the Educated males (% of male labor force) in Lithuania in 1999 to that in 2003?
Your answer should be very brief. 0.97. What is the ratio of the Educated males (% of male labor force) of Mexico in 1999 to that in 2003?
Provide a short and direct response. 1.04. What is the ratio of the Educated males (% of male labor force) in Euro area in 1999 to that in 2004?
Keep it short and to the point. 1.13. What is the ratio of the Educated males (% of male labor force) of Canada in 1999 to that in 2004?
Your answer should be very brief. 1.23. What is the ratio of the Educated males (% of male labor force) in Lithuania in 1999 to that in 2004?
Provide a succinct answer. 1.12. What is the ratio of the Educated males (% of male labor force) in Mexico in 1999 to that in 2004?
Provide a succinct answer. 0.34. What is the ratio of the Educated males (% of male labor force) in Euro area in 1999 to that in 2005?
Provide a short and direct response. 1.15. What is the ratio of the Educated males (% of male labor force) in Canada in 1999 to that in 2005?
Offer a terse response. 1.27. What is the ratio of the Educated males (% of male labor force) in Lithuania in 1999 to that in 2005?
Provide a short and direct response. 1.25. What is the ratio of the Educated males (% of male labor force) of Mexico in 1999 to that in 2005?
Offer a very short reply. 0.34. What is the ratio of the Educated males (% of male labor force) of Euro area in 1999 to that in 2006?
Make the answer very short. 1.16. What is the ratio of the Educated males (% of male labor force) in Canada in 1999 to that in 2006?
Ensure brevity in your answer.  1.3. What is the ratio of the Educated males (% of male labor force) of Lithuania in 1999 to that in 2006?
Your answer should be compact. 1.33. What is the ratio of the Educated males (% of male labor force) in Mexico in 1999 to that in 2006?
Your answer should be compact. 0.35. What is the ratio of the Educated males (% of male labor force) in Euro area in 2000 to that in 2001?
Provide a short and direct response. 1.03. What is the ratio of the Educated males (% of male labor force) of Canada in 2000 to that in 2001?
Your answer should be compact. 1.05. What is the ratio of the Educated males (% of male labor force) in Lithuania in 2000 to that in 2001?
Offer a very short reply. 1.02. What is the ratio of the Educated males (% of male labor force) of Mexico in 2000 to that in 2001?
Your response must be concise. 0.32. What is the ratio of the Educated males (% of male labor force) in Euro area in 2000 to that in 2002?
Keep it short and to the point. 1.04. What is the ratio of the Educated males (% of male labor force) in Canada in 2000 to that in 2002?
Offer a very short reply. 1.06. What is the ratio of the Educated males (% of male labor force) in Lithuania in 2000 to that in 2002?
Ensure brevity in your answer.  1.02. What is the ratio of the Educated males (% of male labor force) in Mexico in 2000 to that in 2002?
Keep it short and to the point. 1.01. What is the ratio of the Educated males (% of male labor force) in Euro area in 2000 to that in 2003?
Keep it short and to the point. 1.06. What is the ratio of the Educated males (% of male labor force) in Canada in 2000 to that in 2003?
Ensure brevity in your answer.  1.12. What is the ratio of the Educated males (% of male labor force) in Lithuania in 2000 to that in 2003?
Keep it short and to the point. 0.96. What is the ratio of the Educated males (% of male labor force) in Euro area in 2000 to that in 2004?
Give a very brief answer. 1.1. What is the ratio of the Educated males (% of male labor force) of Canada in 2000 to that in 2004?
Ensure brevity in your answer.  1.16. What is the ratio of the Educated males (% of male labor force) of Lithuania in 2000 to that in 2004?
Make the answer very short. 1.11. What is the ratio of the Educated males (% of male labor force) in Mexico in 2000 to that in 2004?
Provide a short and direct response. 0.33. What is the ratio of the Educated males (% of male labor force) of Euro area in 2000 to that in 2005?
Your response must be concise. 1.11. What is the ratio of the Educated males (% of male labor force) in Canada in 2000 to that in 2005?
Offer a very short reply. 1.2. What is the ratio of the Educated males (% of male labor force) in Lithuania in 2000 to that in 2005?
Ensure brevity in your answer.  1.24. What is the ratio of the Educated males (% of male labor force) in Mexico in 2000 to that in 2005?
Your answer should be compact. 0.34. What is the ratio of the Educated males (% of male labor force) of Euro area in 2000 to that in 2006?
Keep it short and to the point. 1.13. What is the ratio of the Educated males (% of male labor force) in Canada in 2000 to that in 2006?
Ensure brevity in your answer.  1.23. What is the ratio of the Educated males (% of male labor force) in Lithuania in 2000 to that in 2006?
Your response must be concise. 1.31. What is the ratio of the Educated males (% of male labor force) in Mexico in 2000 to that in 2006?
Keep it short and to the point. 0.34. What is the ratio of the Educated males (% of male labor force) in Euro area in 2001 to that in 2002?
Your answer should be very brief. 1.01. What is the ratio of the Educated males (% of male labor force) of Mexico in 2001 to that in 2002?
Keep it short and to the point. 3.12. What is the ratio of the Educated males (% of male labor force) in Euro area in 2001 to that in 2003?
Offer a terse response. 1.03. What is the ratio of the Educated males (% of male labor force) in Canada in 2001 to that in 2003?
Give a very brief answer. 1.07. What is the ratio of the Educated males (% of male labor force) of Mexico in 2001 to that in 2003?
Keep it short and to the point. 3.13. What is the ratio of the Educated males (% of male labor force) of Euro area in 2001 to that in 2004?
Give a very brief answer. 1.06. What is the ratio of the Educated males (% of male labor force) of Canada in 2001 to that in 2004?
Offer a very short reply. 1.11. What is the ratio of the Educated males (% of male labor force) of Lithuania in 2001 to that in 2004?
Offer a terse response. 1.08. What is the ratio of the Educated males (% of male labor force) of Mexico in 2001 to that in 2004?
Provide a succinct answer. 1.01. What is the ratio of the Educated males (% of male labor force) in Euro area in 2001 to that in 2005?
Your answer should be very brief. 1.08. What is the ratio of the Educated males (% of male labor force) of Canada in 2001 to that in 2005?
Your response must be concise. 1.15. What is the ratio of the Educated males (% of male labor force) in Lithuania in 2001 to that in 2005?
Offer a very short reply. 1.21. What is the ratio of the Educated males (% of male labor force) of Mexico in 2001 to that in 2005?
Ensure brevity in your answer.  1.03. What is the ratio of the Educated males (% of male labor force) of Euro area in 2001 to that in 2006?
Your response must be concise. 1.1. What is the ratio of the Educated males (% of male labor force) in Canada in 2001 to that in 2006?
Your answer should be compact. 1.18. What is the ratio of the Educated males (% of male labor force) of Lithuania in 2001 to that in 2006?
Your response must be concise. 1.29. What is the ratio of the Educated males (% of male labor force) in Mexico in 2001 to that in 2006?
Your answer should be very brief. 1.04. What is the ratio of the Educated males (% of male labor force) of Euro area in 2002 to that in 2003?
Offer a terse response. 1.02. What is the ratio of the Educated males (% of male labor force) in Canada in 2002 to that in 2003?
Offer a very short reply. 1.05. What is the ratio of the Educated males (% of male labor force) in Lithuania in 2002 to that in 2003?
Your answer should be very brief. 0.94. What is the ratio of the Educated males (% of male labor force) of Euro area in 2002 to that in 2004?
Offer a very short reply. 1.05. What is the ratio of the Educated males (% of male labor force) in Canada in 2002 to that in 2004?
Give a very brief answer. 1.09. What is the ratio of the Educated males (% of male labor force) of Lithuania in 2002 to that in 2004?
Ensure brevity in your answer.  1.08. What is the ratio of the Educated males (% of male labor force) in Mexico in 2002 to that in 2004?
Give a very brief answer. 0.33. What is the ratio of the Educated males (% of male labor force) in Euro area in 2002 to that in 2005?
Ensure brevity in your answer.  1.07. What is the ratio of the Educated males (% of male labor force) of Canada in 2002 to that in 2005?
Provide a short and direct response. 1.13. What is the ratio of the Educated males (% of male labor force) in Lithuania in 2002 to that in 2005?
Provide a succinct answer. 1.21. What is the ratio of the Educated males (% of male labor force) in Mexico in 2002 to that in 2005?
Make the answer very short. 0.33. What is the ratio of the Educated males (% of male labor force) of Euro area in 2002 to that in 2006?
Offer a terse response. 1.09. What is the ratio of the Educated males (% of male labor force) of Canada in 2002 to that in 2006?
Offer a terse response. 1.16. What is the ratio of the Educated males (% of male labor force) of Lithuania in 2002 to that in 2006?
Your answer should be compact. 1.29. What is the ratio of the Educated males (% of male labor force) in Mexico in 2002 to that in 2006?
Give a very brief answer. 0.33. What is the ratio of the Educated males (% of male labor force) in Euro area in 2003 to that in 2004?
Your answer should be very brief. 1.03. What is the ratio of the Educated males (% of male labor force) of Canada in 2003 to that in 2004?
Keep it short and to the point. 1.04. What is the ratio of the Educated males (% of male labor force) in Lithuania in 2003 to that in 2004?
Make the answer very short. 1.15. What is the ratio of the Educated males (% of male labor force) of Mexico in 2003 to that in 2004?
Keep it short and to the point. 0.32. What is the ratio of the Educated males (% of male labor force) in Euro area in 2003 to that in 2005?
Provide a short and direct response. 1.05. What is the ratio of the Educated males (% of male labor force) of Canada in 2003 to that in 2005?
Your answer should be very brief. 1.08. What is the ratio of the Educated males (% of male labor force) of Mexico in 2003 to that in 2005?
Provide a succinct answer. 0.33. What is the ratio of the Educated males (% of male labor force) in Euro area in 2003 to that in 2006?
Your answer should be compact. 1.06. What is the ratio of the Educated males (% of male labor force) in Canada in 2003 to that in 2006?
Provide a short and direct response. 1.1. What is the ratio of the Educated males (% of male labor force) of Lithuania in 2003 to that in 2006?
Offer a terse response. 1.37. What is the ratio of the Educated males (% of male labor force) in Mexico in 2003 to that in 2006?
Ensure brevity in your answer.  0.33. What is the ratio of the Educated males (% of male labor force) in Euro area in 2004 to that in 2005?
Your answer should be very brief. 1.02. What is the ratio of the Educated males (% of male labor force) of Canada in 2004 to that in 2005?
Keep it short and to the point. 1.04. What is the ratio of the Educated males (% of male labor force) of Lithuania in 2004 to that in 2005?
Make the answer very short. 1.12. What is the ratio of the Educated males (% of male labor force) in Mexico in 2004 to that in 2005?
Provide a succinct answer. 1.02. What is the ratio of the Educated males (% of male labor force) of Euro area in 2004 to that in 2006?
Ensure brevity in your answer.  1.03. What is the ratio of the Educated males (% of male labor force) of Canada in 2004 to that in 2006?
Give a very brief answer. 1.06. What is the ratio of the Educated males (% of male labor force) of Lithuania in 2004 to that in 2006?
Offer a terse response. 1.19. What is the ratio of the Educated males (% of male labor force) of Mexico in 2004 to that in 2006?
Your answer should be very brief. 1.02. What is the ratio of the Educated males (% of male labor force) in Euro area in 2005 to that in 2006?
Provide a short and direct response. 1.01. What is the ratio of the Educated males (% of male labor force) of Canada in 2005 to that in 2006?
Keep it short and to the point. 1.02. What is the ratio of the Educated males (% of male labor force) of Lithuania in 2005 to that in 2006?
Make the answer very short. 1.06. What is the ratio of the Educated males (% of male labor force) in Mexico in 2005 to that in 2006?
Provide a short and direct response. 1. What is the difference between the highest and the second highest Educated males (% of male labor force) in Euro area?
Ensure brevity in your answer.  1.04. What is the difference between the highest and the second highest Educated males (% of male labor force) of Canada?
Provide a succinct answer. 1.1. What is the difference between the highest and the second highest Educated males (% of male labor force) of Mexico?
Make the answer very short. 0.9. What is the difference between the highest and the lowest Educated males (% of male labor force) in Euro area?
Your response must be concise. 5.08. What is the difference between the highest and the lowest Educated males (% of male labor force) of Canada?
Offer a terse response. 4.9. What is the difference between the highest and the lowest Educated males (% of male labor force) in Lithuania?
Keep it short and to the point. 4.1. What is the difference between the highest and the lowest Educated males (% of male labor force) in Mexico?
Make the answer very short. 42.7. 